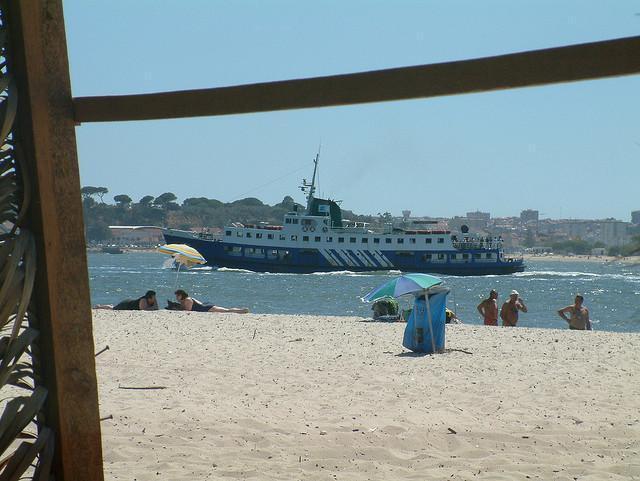How many umbrellas are there?
Give a very brief answer. 2. How many boats can be seen?
Give a very brief answer. 1. How many cows are standing up?
Give a very brief answer. 0. 